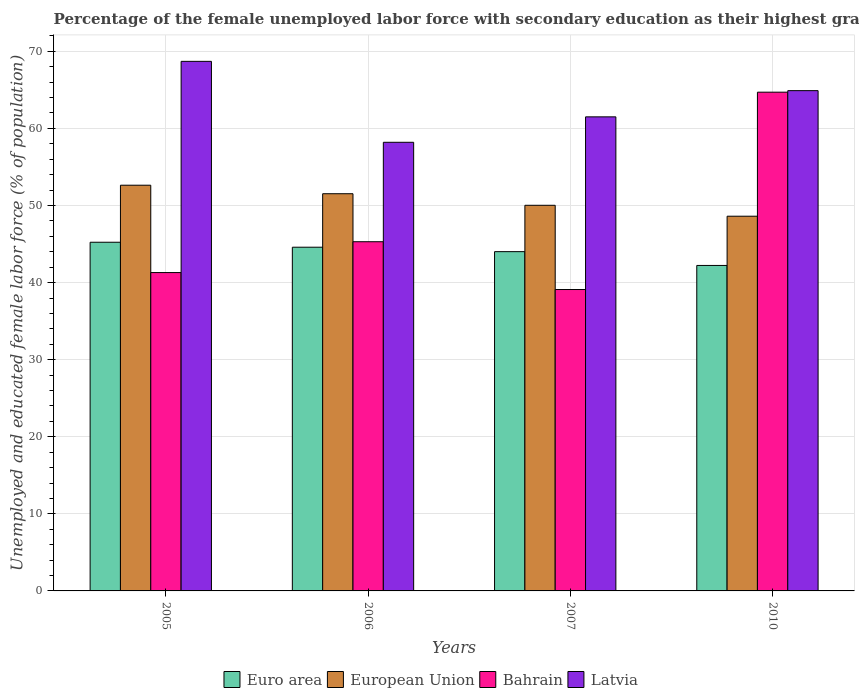How many different coloured bars are there?
Your answer should be very brief. 4. How many bars are there on the 1st tick from the left?
Offer a very short reply. 4. How many bars are there on the 3rd tick from the right?
Provide a succinct answer. 4. What is the label of the 3rd group of bars from the left?
Your response must be concise. 2007. What is the percentage of the unemployed female labor force with secondary education in Euro area in 2007?
Provide a succinct answer. 44.01. Across all years, what is the maximum percentage of the unemployed female labor force with secondary education in Euro area?
Ensure brevity in your answer.  45.23. Across all years, what is the minimum percentage of the unemployed female labor force with secondary education in European Union?
Your response must be concise. 48.61. In which year was the percentage of the unemployed female labor force with secondary education in Bahrain maximum?
Make the answer very short. 2010. What is the total percentage of the unemployed female labor force with secondary education in European Union in the graph?
Offer a very short reply. 202.8. What is the difference between the percentage of the unemployed female labor force with secondary education in Euro area in 2007 and that in 2010?
Offer a terse response. 1.79. What is the difference between the percentage of the unemployed female labor force with secondary education in Latvia in 2010 and the percentage of the unemployed female labor force with secondary education in European Union in 2006?
Your response must be concise. 13.37. What is the average percentage of the unemployed female labor force with secondary education in Euro area per year?
Give a very brief answer. 44.02. In the year 2010, what is the difference between the percentage of the unemployed female labor force with secondary education in European Union and percentage of the unemployed female labor force with secondary education in Euro area?
Your answer should be very brief. 6.39. What is the ratio of the percentage of the unemployed female labor force with secondary education in Euro area in 2005 to that in 2006?
Your response must be concise. 1.01. Is the percentage of the unemployed female labor force with secondary education in Euro area in 2005 less than that in 2006?
Ensure brevity in your answer.  No. What is the difference between the highest and the second highest percentage of the unemployed female labor force with secondary education in European Union?
Make the answer very short. 1.11. What is the difference between the highest and the lowest percentage of the unemployed female labor force with secondary education in Latvia?
Offer a very short reply. 10.5. Is the sum of the percentage of the unemployed female labor force with secondary education in Bahrain in 2005 and 2007 greater than the maximum percentage of the unemployed female labor force with secondary education in Euro area across all years?
Keep it short and to the point. Yes. Is it the case that in every year, the sum of the percentage of the unemployed female labor force with secondary education in Euro area and percentage of the unemployed female labor force with secondary education in European Union is greater than the sum of percentage of the unemployed female labor force with secondary education in Latvia and percentage of the unemployed female labor force with secondary education in Bahrain?
Offer a very short reply. Yes. What does the 1st bar from the right in 2006 represents?
Give a very brief answer. Latvia. Is it the case that in every year, the sum of the percentage of the unemployed female labor force with secondary education in Bahrain and percentage of the unemployed female labor force with secondary education in Euro area is greater than the percentage of the unemployed female labor force with secondary education in Latvia?
Your answer should be compact. Yes. What is the difference between two consecutive major ticks on the Y-axis?
Offer a terse response. 10. Does the graph contain any zero values?
Provide a short and direct response. No. Does the graph contain grids?
Ensure brevity in your answer.  Yes. How are the legend labels stacked?
Offer a very short reply. Horizontal. What is the title of the graph?
Make the answer very short. Percentage of the female unemployed labor force with secondary education as their highest grade. Does "Australia" appear as one of the legend labels in the graph?
Ensure brevity in your answer.  No. What is the label or title of the Y-axis?
Your answer should be very brief. Unemployed and educated female labor force (% of population). What is the Unemployed and educated female labor force (% of population) in Euro area in 2005?
Provide a short and direct response. 45.23. What is the Unemployed and educated female labor force (% of population) in European Union in 2005?
Offer a very short reply. 52.63. What is the Unemployed and educated female labor force (% of population) of Bahrain in 2005?
Offer a very short reply. 41.3. What is the Unemployed and educated female labor force (% of population) of Latvia in 2005?
Offer a very short reply. 68.7. What is the Unemployed and educated female labor force (% of population) in Euro area in 2006?
Give a very brief answer. 44.59. What is the Unemployed and educated female labor force (% of population) in European Union in 2006?
Provide a short and direct response. 51.53. What is the Unemployed and educated female labor force (% of population) of Bahrain in 2006?
Keep it short and to the point. 45.3. What is the Unemployed and educated female labor force (% of population) of Latvia in 2006?
Your response must be concise. 58.2. What is the Unemployed and educated female labor force (% of population) of Euro area in 2007?
Your response must be concise. 44.01. What is the Unemployed and educated female labor force (% of population) in European Union in 2007?
Make the answer very short. 50.03. What is the Unemployed and educated female labor force (% of population) in Bahrain in 2007?
Provide a succinct answer. 39.1. What is the Unemployed and educated female labor force (% of population) of Latvia in 2007?
Your answer should be very brief. 61.5. What is the Unemployed and educated female labor force (% of population) in Euro area in 2010?
Your response must be concise. 42.22. What is the Unemployed and educated female labor force (% of population) of European Union in 2010?
Ensure brevity in your answer.  48.61. What is the Unemployed and educated female labor force (% of population) in Bahrain in 2010?
Ensure brevity in your answer.  64.7. What is the Unemployed and educated female labor force (% of population) of Latvia in 2010?
Your answer should be compact. 64.9. Across all years, what is the maximum Unemployed and educated female labor force (% of population) in Euro area?
Your answer should be very brief. 45.23. Across all years, what is the maximum Unemployed and educated female labor force (% of population) of European Union?
Give a very brief answer. 52.63. Across all years, what is the maximum Unemployed and educated female labor force (% of population) of Bahrain?
Offer a terse response. 64.7. Across all years, what is the maximum Unemployed and educated female labor force (% of population) of Latvia?
Your response must be concise. 68.7. Across all years, what is the minimum Unemployed and educated female labor force (% of population) in Euro area?
Offer a terse response. 42.22. Across all years, what is the minimum Unemployed and educated female labor force (% of population) of European Union?
Offer a terse response. 48.61. Across all years, what is the minimum Unemployed and educated female labor force (% of population) of Bahrain?
Your response must be concise. 39.1. Across all years, what is the minimum Unemployed and educated female labor force (% of population) of Latvia?
Provide a succinct answer. 58.2. What is the total Unemployed and educated female labor force (% of population) of Euro area in the graph?
Make the answer very short. 176.06. What is the total Unemployed and educated female labor force (% of population) in European Union in the graph?
Keep it short and to the point. 202.8. What is the total Unemployed and educated female labor force (% of population) of Bahrain in the graph?
Make the answer very short. 190.4. What is the total Unemployed and educated female labor force (% of population) of Latvia in the graph?
Your response must be concise. 253.3. What is the difference between the Unemployed and educated female labor force (% of population) in Euro area in 2005 and that in 2006?
Give a very brief answer. 0.65. What is the difference between the Unemployed and educated female labor force (% of population) in European Union in 2005 and that in 2006?
Give a very brief answer. 1.11. What is the difference between the Unemployed and educated female labor force (% of population) in Bahrain in 2005 and that in 2006?
Provide a succinct answer. -4. What is the difference between the Unemployed and educated female labor force (% of population) in Latvia in 2005 and that in 2006?
Offer a terse response. 10.5. What is the difference between the Unemployed and educated female labor force (% of population) of Euro area in 2005 and that in 2007?
Your answer should be compact. 1.22. What is the difference between the Unemployed and educated female labor force (% of population) of European Union in 2005 and that in 2007?
Offer a very short reply. 2.61. What is the difference between the Unemployed and educated female labor force (% of population) in Euro area in 2005 and that in 2010?
Your answer should be compact. 3.01. What is the difference between the Unemployed and educated female labor force (% of population) of European Union in 2005 and that in 2010?
Your response must be concise. 4.02. What is the difference between the Unemployed and educated female labor force (% of population) of Bahrain in 2005 and that in 2010?
Keep it short and to the point. -23.4. What is the difference between the Unemployed and educated female labor force (% of population) of Latvia in 2005 and that in 2010?
Ensure brevity in your answer.  3.8. What is the difference between the Unemployed and educated female labor force (% of population) in Euro area in 2006 and that in 2007?
Your answer should be very brief. 0.58. What is the difference between the Unemployed and educated female labor force (% of population) of European Union in 2006 and that in 2007?
Your answer should be compact. 1.5. What is the difference between the Unemployed and educated female labor force (% of population) of Bahrain in 2006 and that in 2007?
Your response must be concise. 6.2. What is the difference between the Unemployed and educated female labor force (% of population) in Latvia in 2006 and that in 2007?
Keep it short and to the point. -3.3. What is the difference between the Unemployed and educated female labor force (% of population) in Euro area in 2006 and that in 2010?
Your answer should be compact. 2.36. What is the difference between the Unemployed and educated female labor force (% of population) in European Union in 2006 and that in 2010?
Offer a very short reply. 2.92. What is the difference between the Unemployed and educated female labor force (% of population) in Bahrain in 2006 and that in 2010?
Your answer should be very brief. -19.4. What is the difference between the Unemployed and educated female labor force (% of population) in Euro area in 2007 and that in 2010?
Your response must be concise. 1.79. What is the difference between the Unemployed and educated female labor force (% of population) in European Union in 2007 and that in 2010?
Your answer should be very brief. 1.42. What is the difference between the Unemployed and educated female labor force (% of population) in Bahrain in 2007 and that in 2010?
Make the answer very short. -25.6. What is the difference between the Unemployed and educated female labor force (% of population) of Latvia in 2007 and that in 2010?
Ensure brevity in your answer.  -3.4. What is the difference between the Unemployed and educated female labor force (% of population) in Euro area in 2005 and the Unemployed and educated female labor force (% of population) in European Union in 2006?
Keep it short and to the point. -6.29. What is the difference between the Unemployed and educated female labor force (% of population) of Euro area in 2005 and the Unemployed and educated female labor force (% of population) of Bahrain in 2006?
Offer a very short reply. -0.07. What is the difference between the Unemployed and educated female labor force (% of population) of Euro area in 2005 and the Unemployed and educated female labor force (% of population) of Latvia in 2006?
Provide a succinct answer. -12.97. What is the difference between the Unemployed and educated female labor force (% of population) in European Union in 2005 and the Unemployed and educated female labor force (% of population) in Bahrain in 2006?
Your response must be concise. 7.33. What is the difference between the Unemployed and educated female labor force (% of population) in European Union in 2005 and the Unemployed and educated female labor force (% of population) in Latvia in 2006?
Provide a short and direct response. -5.57. What is the difference between the Unemployed and educated female labor force (% of population) of Bahrain in 2005 and the Unemployed and educated female labor force (% of population) of Latvia in 2006?
Offer a very short reply. -16.9. What is the difference between the Unemployed and educated female labor force (% of population) in Euro area in 2005 and the Unemployed and educated female labor force (% of population) in European Union in 2007?
Provide a succinct answer. -4.79. What is the difference between the Unemployed and educated female labor force (% of population) in Euro area in 2005 and the Unemployed and educated female labor force (% of population) in Bahrain in 2007?
Your response must be concise. 6.13. What is the difference between the Unemployed and educated female labor force (% of population) of Euro area in 2005 and the Unemployed and educated female labor force (% of population) of Latvia in 2007?
Your response must be concise. -16.27. What is the difference between the Unemployed and educated female labor force (% of population) in European Union in 2005 and the Unemployed and educated female labor force (% of population) in Bahrain in 2007?
Your answer should be compact. 13.53. What is the difference between the Unemployed and educated female labor force (% of population) of European Union in 2005 and the Unemployed and educated female labor force (% of population) of Latvia in 2007?
Give a very brief answer. -8.87. What is the difference between the Unemployed and educated female labor force (% of population) of Bahrain in 2005 and the Unemployed and educated female labor force (% of population) of Latvia in 2007?
Give a very brief answer. -20.2. What is the difference between the Unemployed and educated female labor force (% of population) of Euro area in 2005 and the Unemployed and educated female labor force (% of population) of European Union in 2010?
Keep it short and to the point. -3.38. What is the difference between the Unemployed and educated female labor force (% of population) of Euro area in 2005 and the Unemployed and educated female labor force (% of population) of Bahrain in 2010?
Keep it short and to the point. -19.47. What is the difference between the Unemployed and educated female labor force (% of population) in Euro area in 2005 and the Unemployed and educated female labor force (% of population) in Latvia in 2010?
Give a very brief answer. -19.67. What is the difference between the Unemployed and educated female labor force (% of population) in European Union in 2005 and the Unemployed and educated female labor force (% of population) in Bahrain in 2010?
Give a very brief answer. -12.07. What is the difference between the Unemployed and educated female labor force (% of population) of European Union in 2005 and the Unemployed and educated female labor force (% of population) of Latvia in 2010?
Your response must be concise. -12.27. What is the difference between the Unemployed and educated female labor force (% of population) in Bahrain in 2005 and the Unemployed and educated female labor force (% of population) in Latvia in 2010?
Provide a succinct answer. -23.6. What is the difference between the Unemployed and educated female labor force (% of population) of Euro area in 2006 and the Unemployed and educated female labor force (% of population) of European Union in 2007?
Provide a short and direct response. -5.44. What is the difference between the Unemployed and educated female labor force (% of population) of Euro area in 2006 and the Unemployed and educated female labor force (% of population) of Bahrain in 2007?
Make the answer very short. 5.49. What is the difference between the Unemployed and educated female labor force (% of population) of Euro area in 2006 and the Unemployed and educated female labor force (% of population) of Latvia in 2007?
Make the answer very short. -16.91. What is the difference between the Unemployed and educated female labor force (% of population) of European Union in 2006 and the Unemployed and educated female labor force (% of population) of Bahrain in 2007?
Your answer should be compact. 12.43. What is the difference between the Unemployed and educated female labor force (% of population) of European Union in 2006 and the Unemployed and educated female labor force (% of population) of Latvia in 2007?
Keep it short and to the point. -9.97. What is the difference between the Unemployed and educated female labor force (% of population) of Bahrain in 2006 and the Unemployed and educated female labor force (% of population) of Latvia in 2007?
Provide a succinct answer. -16.2. What is the difference between the Unemployed and educated female labor force (% of population) in Euro area in 2006 and the Unemployed and educated female labor force (% of population) in European Union in 2010?
Provide a short and direct response. -4.02. What is the difference between the Unemployed and educated female labor force (% of population) in Euro area in 2006 and the Unemployed and educated female labor force (% of population) in Bahrain in 2010?
Provide a succinct answer. -20.11. What is the difference between the Unemployed and educated female labor force (% of population) in Euro area in 2006 and the Unemployed and educated female labor force (% of population) in Latvia in 2010?
Your answer should be very brief. -20.31. What is the difference between the Unemployed and educated female labor force (% of population) of European Union in 2006 and the Unemployed and educated female labor force (% of population) of Bahrain in 2010?
Your response must be concise. -13.17. What is the difference between the Unemployed and educated female labor force (% of population) in European Union in 2006 and the Unemployed and educated female labor force (% of population) in Latvia in 2010?
Give a very brief answer. -13.37. What is the difference between the Unemployed and educated female labor force (% of population) in Bahrain in 2006 and the Unemployed and educated female labor force (% of population) in Latvia in 2010?
Your answer should be compact. -19.6. What is the difference between the Unemployed and educated female labor force (% of population) in Euro area in 2007 and the Unemployed and educated female labor force (% of population) in European Union in 2010?
Give a very brief answer. -4.6. What is the difference between the Unemployed and educated female labor force (% of population) in Euro area in 2007 and the Unemployed and educated female labor force (% of population) in Bahrain in 2010?
Provide a short and direct response. -20.69. What is the difference between the Unemployed and educated female labor force (% of population) of Euro area in 2007 and the Unemployed and educated female labor force (% of population) of Latvia in 2010?
Provide a short and direct response. -20.89. What is the difference between the Unemployed and educated female labor force (% of population) of European Union in 2007 and the Unemployed and educated female labor force (% of population) of Bahrain in 2010?
Make the answer very short. -14.67. What is the difference between the Unemployed and educated female labor force (% of population) in European Union in 2007 and the Unemployed and educated female labor force (% of population) in Latvia in 2010?
Provide a succinct answer. -14.87. What is the difference between the Unemployed and educated female labor force (% of population) in Bahrain in 2007 and the Unemployed and educated female labor force (% of population) in Latvia in 2010?
Offer a terse response. -25.8. What is the average Unemployed and educated female labor force (% of population) of Euro area per year?
Your response must be concise. 44.02. What is the average Unemployed and educated female labor force (% of population) in European Union per year?
Offer a very short reply. 50.7. What is the average Unemployed and educated female labor force (% of population) in Bahrain per year?
Make the answer very short. 47.6. What is the average Unemployed and educated female labor force (% of population) in Latvia per year?
Your answer should be very brief. 63.33. In the year 2005, what is the difference between the Unemployed and educated female labor force (% of population) in Euro area and Unemployed and educated female labor force (% of population) in European Union?
Offer a terse response. -7.4. In the year 2005, what is the difference between the Unemployed and educated female labor force (% of population) in Euro area and Unemployed and educated female labor force (% of population) in Bahrain?
Provide a short and direct response. 3.93. In the year 2005, what is the difference between the Unemployed and educated female labor force (% of population) of Euro area and Unemployed and educated female labor force (% of population) of Latvia?
Provide a short and direct response. -23.47. In the year 2005, what is the difference between the Unemployed and educated female labor force (% of population) of European Union and Unemployed and educated female labor force (% of population) of Bahrain?
Keep it short and to the point. 11.33. In the year 2005, what is the difference between the Unemployed and educated female labor force (% of population) in European Union and Unemployed and educated female labor force (% of population) in Latvia?
Keep it short and to the point. -16.07. In the year 2005, what is the difference between the Unemployed and educated female labor force (% of population) of Bahrain and Unemployed and educated female labor force (% of population) of Latvia?
Your answer should be very brief. -27.4. In the year 2006, what is the difference between the Unemployed and educated female labor force (% of population) in Euro area and Unemployed and educated female labor force (% of population) in European Union?
Keep it short and to the point. -6.94. In the year 2006, what is the difference between the Unemployed and educated female labor force (% of population) in Euro area and Unemployed and educated female labor force (% of population) in Bahrain?
Provide a succinct answer. -0.71. In the year 2006, what is the difference between the Unemployed and educated female labor force (% of population) of Euro area and Unemployed and educated female labor force (% of population) of Latvia?
Keep it short and to the point. -13.61. In the year 2006, what is the difference between the Unemployed and educated female labor force (% of population) of European Union and Unemployed and educated female labor force (% of population) of Bahrain?
Offer a very short reply. 6.23. In the year 2006, what is the difference between the Unemployed and educated female labor force (% of population) of European Union and Unemployed and educated female labor force (% of population) of Latvia?
Offer a very short reply. -6.67. In the year 2007, what is the difference between the Unemployed and educated female labor force (% of population) in Euro area and Unemployed and educated female labor force (% of population) in European Union?
Your answer should be compact. -6.01. In the year 2007, what is the difference between the Unemployed and educated female labor force (% of population) of Euro area and Unemployed and educated female labor force (% of population) of Bahrain?
Make the answer very short. 4.91. In the year 2007, what is the difference between the Unemployed and educated female labor force (% of population) in Euro area and Unemployed and educated female labor force (% of population) in Latvia?
Offer a terse response. -17.49. In the year 2007, what is the difference between the Unemployed and educated female labor force (% of population) of European Union and Unemployed and educated female labor force (% of population) of Bahrain?
Offer a very short reply. 10.93. In the year 2007, what is the difference between the Unemployed and educated female labor force (% of population) of European Union and Unemployed and educated female labor force (% of population) of Latvia?
Your answer should be very brief. -11.47. In the year 2007, what is the difference between the Unemployed and educated female labor force (% of population) of Bahrain and Unemployed and educated female labor force (% of population) of Latvia?
Provide a succinct answer. -22.4. In the year 2010, what is the difference between the Unemployed and educated female labor force (% of population) in Euro area and Unemployed and educated female labor force (% of population) in European Union?
Give a very brief answer. -6.39. In the year 2010, what is the difference between the Unemployed and educated female labor force (% of population) of Euro area and Unemployed and educated female labor force (% of population) of Bahrain?
Give a very brief answer. -22.48. In the year 2010, what is the difference between the Unemployed and educated female labor force (% of population) of Euro area and Unemployed and educated female labor force (% of population) of Latvia?
Your response must be concise. -22.68. In the year 2010, what is the difference between the Unemployed and educated female labor force (% of population) of European Union and Unemployed and educated female labor force (% of population) of Bahrain?
Ensure brevity in your answer.  -16.09. In the year 2010, what is the difference between the Unemployed and educated female labor force (% of population) of European Union and Unemployed and educated female labor force (% of population) of Latvia?
Ensure brevity in your answer.  -16.29. In the year 2010, what is the difference between the Unemployed and educated female labor force (% of population) in Bahrain and Unemployed and educated female labor force (% of population) in Latvia?
Your answer should be compact. -0.2. What is the ratio of the Unemployed and educated female labor force (% of population) of Euro area in 2005 to that in 2006?
Offer a very short reply. 1.01. What is the ratio of the Unemployed and educated female labor force (% of population) in European Union in 2005 to that in 2006?
Provide a short and direct response. 1.02. What is the ratio of the Unemployed and educated female labor force (% of population) in Bahrain in 2005 to that in 2006?
Keep it short and to the point. 0.91. What is the ratio of the Unemployed and educated female labor force (% of population) in Latvia in 2005 to that in 2006?
Your answer should be compact. 1.18. What is the ratio of the Unemployed and educated female labor force (% of population) in Euro area in 2005 to that in 2007?
Provide a short and direct response. 1.03. What is the ratio of the Unemployed and educated female labor force (% of population) of European Union in 2005 to that in 2007?
Your response must be concise. 1.05. What is the ratio of the Unemployed and educated female labor force (% of population) in Bahrain in 2005 to that in 2007?
Ensure brevity in your answer.  1.06. What is the ratio of the Unemployed and educated female labor force (% of population) of Latvia in 2005 to that in 2007?
Your answer should be very brief. 1.12. What is the ratio of the Unemployed and educated female labor force (% of population) in Euro area in 2005 to that in 2010?
Your response must be concise. 1.07. What is the ratio of the Unemployed and educated female labor force (% of population) of European Union in 2005 to that in 2010?
Keep it short and to the point. 1.08. What is the ratio of the Unemployed and educated female labor force (% of population) of Bahrain in 2005 to that in 2010?
Offer a terse response. 0.64. What is the ratio of the Unemployed and educated female labor force (% of population) in Latvia in 2005 to that in 2010?
Offer a very short reply. 1.06. What is the ratio of the Unemployed and educated female labor force (% of population) of Euro area in 2006 to that in 2007?
Make the answer very short. 1.01. What is the ratio of the Unemployed and educated female labor force (% of population) in Bahrain in 2006 to that in 2007?
Your response must be concise. 1.16. What is the ratio of the Unemployed and educated female labor force (% of population) of Latvia in 2006 to that in 2007?
Offer a very short reply. 0.95. What is the ratio of the Unemployed and educated female labor force (% of population) of Euro area in 2006 to that in 2010?
Your response must be concise. 1.06. What is the ratio of the Unemployed and educated female labor force (% of population) of European Union in 2006 to that in 2010?
Give a very brief answer. 1.06. What is the ratio of the Unemployed and educated female labor force (% of population) in Bahrain in 2006 to that in 2010?
Offer a very short reply. 0.7. What is the ratio of the Unemployed and educated female labor force (% of population) in Latvia in 2006 to that in 2010?
Your answer should be very brief. 0.9. What is the ratio of the Unemployed and educated female labor force (% of population) of Euro area in 2007 to that in 2010?
Your response must be concise. 1.04. What is the ratio of the Unemployed and educated female labor force (% of population) in European Union in 2007 to that in 2010?
Keep it short and to the point. 1.03. What is the ratio of the Unemployed and educated female labor force (% of population) in Bahrain in 2007 to that in 2010?
Your answer should be very brief. 0.6. What is the ratio of the Unemployed and educated female labor force (% of population) of Latvia in 2007 to that in 2010?
Give a very brief answer. 0.95. What is the difference between the highest and the second highest Unemployed and educated female labor force (% of population) of Euro area?
Your response must be concise. 0.65. What is the difference between the highest and the second highest Unemployed and educated female labor force (% of population) in European Union?
Give a very brief answer. 1.11. What is the difference between the highest and the second highest Unemployed and educated female labor force (% of population) of Bahrain?
Your answer should be compact. 19.4. What is the difference between the highest and the second highest Unemployed and educated female labor force (% of population) of Latvia?
Ensure brevity in your answer.  3.8. What is the difference between the highest and the lowest Unemployed and educated female labor force (% of population) of Euro area?
Offer a terse response. 3.01. What is the difference between the highest and the lowest Unemployed and educated female labor force (% of population) of European Union?
Provide a short and direct response. 4.02. What is the difference between the highest and the lowest Unemployed and educated female labor force (% of population) of Bahrain?
Offer a terse response. 25.6. 